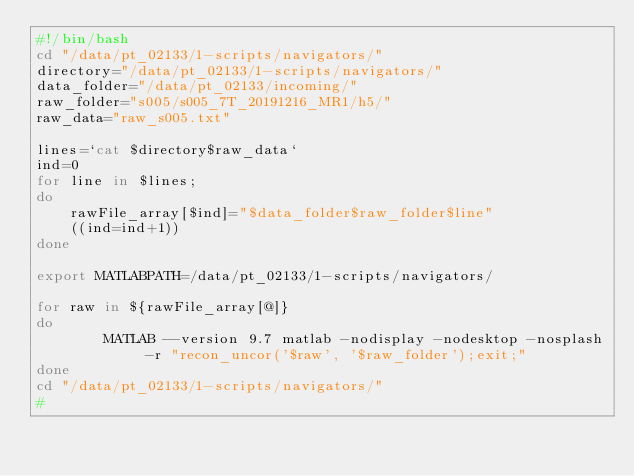Convert code to text. <code><loc_0><loc_0><loc_500><loc_500><_Bash_>#!/bin/bash
cd "/data/pt_02133/1-scripts/navigators/"
directory="/data/pt_02133/1-scripts/navigators/"
data_folder="/data/pt_02133/incoming/"
raw_folder="s005/s005_7T_20191216_MR1/h5/"
raw_data="raw_s005.txt"

lines=`cat $directory$raw_data`
ind=0
for line in $lines;
do
	rawFile_array[$ind]="$data_folder$raw_folder$line"
	((ind=ind+1))
done

export MATLABPATH=/data/pt_02133/1-scripts/navigators/

for raw in ${rawFile_array[@]}
do        
        MATLAB --version 9.7 matlab -nodisplay -nodesktop -nosplash -r "recon_uncor('$raw', '$raw_folder');exit;"
done
cd "/data/pt_02133/1-scripts/navigators/"
# 
</code> 